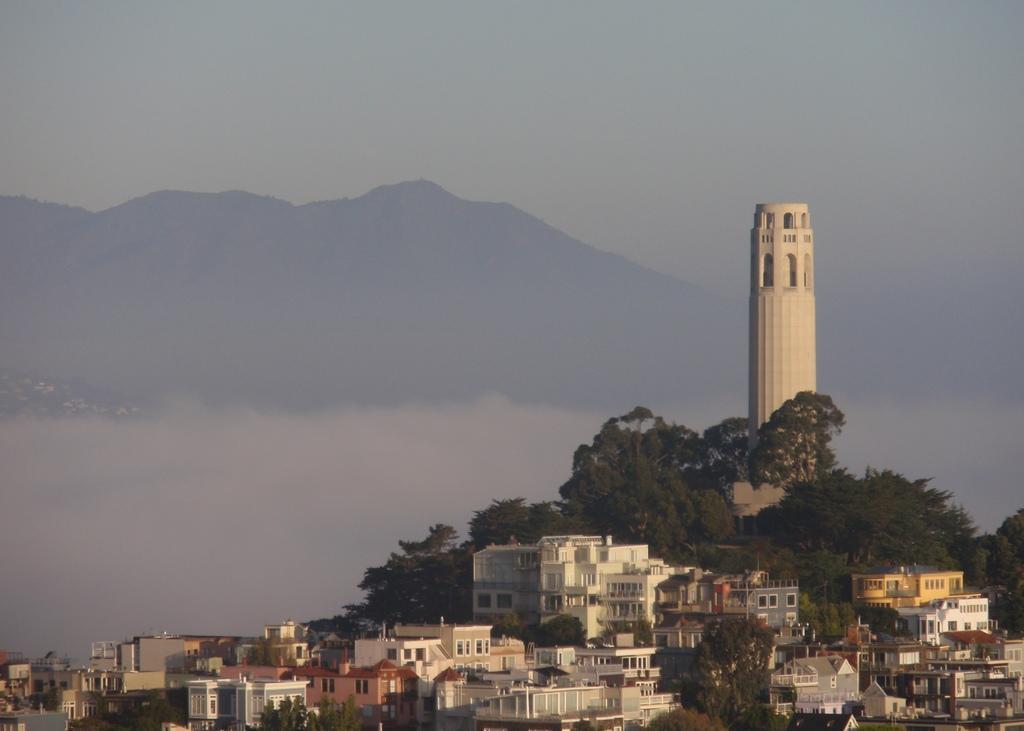How would you summarize this image in a sentence or two? In this picture we can see few buildings, trees and a tower, in the background we can see hills. 